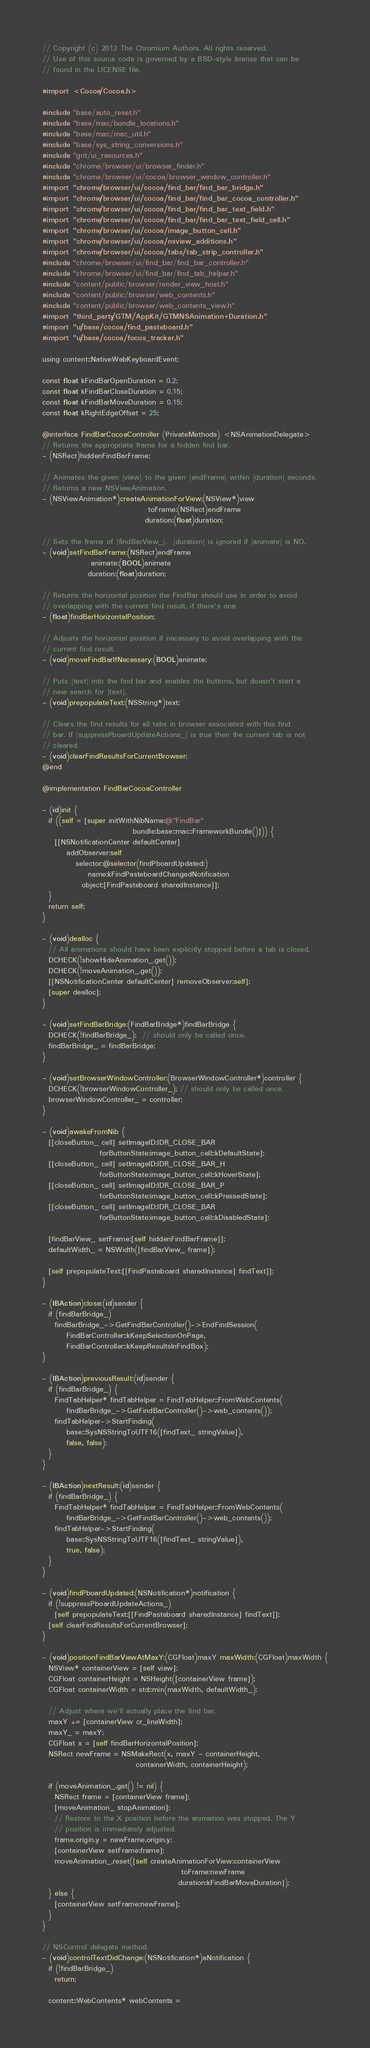Convert code to text. <code><loc_0><loc_0><loc_500><loc_500><_ObjectiveC_>// Copyright (c) 2012 The Chromium Authors. All rights reserved.
// Use of this source code is governed by a BSD-style license that can be
// found in the LICENSE file.

#import <Cocoa/Cocoa.h>

#include "base/auto_reset.h"
#include "base/mac/bundle_locations.h"
#include "base/mac/mac_util.h"
#include "base/sys_string_conversions.h"
#include "grit/ui_resources.h"
#include "chrome/browser/ui/browser_finder.h"
#include "chrome/browser/ui/cocoa/browser_window_controller.h"
#import "chrome/browser/ui/cocoa/find_bar/find_bar_bridge.h"
#import "chrome/browser/ui/cocoa/find_bar/find_bar_cocoa_controller.h"
#import "chrome/browser/ui/cocoa/find_bar/find_bar_text_field.h"
#import "chrome/browser/ui/cocoa/find_bar/find_bar_text_field_cell.h"
#import "chrome/browser/ui/cocoa/image_button_cell.h"
#import "chrome/browser/ui/cocoa/nsview_additions.h"
#import "chrome/browser/ui/cocoa/tabs/tab_strip_controller.h"
#include "chrome/browser/ui/find_bar/find_bar_controller.h"
#include "chrome/browser/ui/find_bar/find_tab_helper.h"
#include "content/public/browser/render_view_host.h"
#include "content/public/browser/web_contents.h"
#include "content/public/browser/web_contents_view.h"
#import "third_party/GTM/AppKit/GTMNSAnimation+Duration.h"
#import "ui/base/cocoa/find_pasteboard.h"
#import "ui/base/cocoa/focus_tracker.h"

using content::NativeWebKeyboardEvent;

const float kFindBarOpenDuration = 0.2;
const float kFindBarCloseDuration = 0.15;
const float kFindBarMoveDuration = 0.15;
const float kRightEdgeOffset = 25;

@interface FindBarCocoaController (PrivateMethods) <NSAnimationDelegate>
// Returns the appropriate frame for a hidden find bar.
- (NSRect)hiddenFindBarFrame;

// Animates the given |view| to the given |endFrame| within |duration| seconds.
// Returns a new NSViewAnimation.
- (NSViewAnimation*)createAnimationForView:(NSView*)view
                                   toFrame:(NSRect)endFrame
                                  duration:(float)duration;

// Sets the frame of |findBarView_|.  |duration| is ignored if |animate| is NO.
- (void)setFindBarFrame:(NSRect)endFrame
                animate:(BOOL)animate
               duration:(float)duration;

// Returns the horizontal position the FindBar should use in order to avoid
// overlapping with the current find result, if there's one.
- (float)findBarHorizontalPosition;

// Adjusts the horizontal position if necessary to avoid overlapping with the
// current find result.
- (void)moveFindBarIfNecessary:(BOOL)animate;

// Puts |text| into the find bar and enables the buttons, but doesn't start a
// new search for |text|.
- (void)prepopulateText:(NSString*)text;

// Clears the find results for all tabs in browser associated with this find
// bar. If |suppressPboardUpdateActions_| is true then the current tab is not
// cleared.
- (void)clearFindResultsForCurrentBrowser;
@end

@implementation FindBarCocoaController

- (id)init {
  if ((self = [super initWithNibName:@"FindBar"
                              bundle:base::mac::FrameworkBundle()])) {
    [[NSNotificationCenter defaultCenter]
        addObserver:self
           selector:@selector(findPboardUpdated:)
               name:kFindPasteboardChangedNotification
             object:[FindPasteboard sharedInstance]];
  }
  return self;
}

- (void)dealloc {
  // All animations should have been explicitly stopped before a tab is closed.
  DCHECK(!showHideAnimation_.get());
  DCHECK(!moveAnimation_.get());
  [[NSNotificationCenter defaultCenter] removeObserver:self];
  [super dealloc];
}

- (void)setFindBarBridge:(FindBarBridge*)findBarBridge {
  DCHECK(!findBarBridge_);  // should only be called once.
  findBarBridge_ = findBarBridge;
}

- (void)setBrowserWindowController:(BrowserWindowController*)controller {
  DCHECK(!browserWindowController_); // should only be called once.
  browserWindowController_ = controller;
}

- (void)awakeFromNib {
  [[closeButton_ cell] setImageID:IDR_CLOSE_BAR
                   forButtonState:image_button_cell::kDefaultState];
  [[closeButton_ cell] setImageID:IDR_CLOSE_BAR_H
                   forButtonState:image_button_cell::kHoverState];
  [[closeButton_ cell] setImageID:IDR_CLOSE_BAR_P
                   forButtonState:image_button_cell::kPressedState];
  [[closeButton_ cell] setImageID:IDR_CLOSE_BAR
                   forButtonState:image_button_cell::kDisabledState];

  [findBarView_ setFrame:[self hiddenFindBarFrame]];
  defaultWidth_ = NSWidth([findBarView_ frame]);

  [self prepopulateText:[[FindPasteboard sharedInstance] findText]];
}

- (IBAction)close:(id)sender {
  if (findBarBridge_)
    findBarBridge_->GetFindBarController()->EndFindSession(
        FindBarController::kKeepSelectionOnPage,
        FindBarController::kKeepResultsInFindBox);
}

- (IBAction)previousResult:(id)sender {
  if (findBarBridge_) {
    FindTabHelper* findTabHelper = FindTabHelper::FromWebContents(
        findBarBridge_->GetFindBarController()->web_contents());
    findTabHelper->StartFinding(
        base::SysNSStringToUTF16([findText_ stringValue]),
        false, false);
  }
}

- (IBAction)nextResult:(id)sender {
  if (findBarBridge_) {
    FindTabHelper* findTabHelper = FindTabHelper::FromWebContents(
        findBarBridge_->GetFindBarController()->web_contents());
    findTabHelper->StartFinding(
        base::SysNSStringToUTF16([findText_ stringValue]),
        true, false);
  }
}

- (void)findPboardUpdated:(NSNotification*)notification {
  if (!suppressPboardUpdateActions_)
    [self prepopulateText:[[FindPasteboard sharedInstance] findText]];
  [self clearFindResultsForCurrentBrowser];
}

- (void)positionFindBarViewAtMaxY:(CGFloat)maxY maxWidth:(CGFloat)maxWidth {
  NSView* containerView = [self view];
  CGFloat containerHeight = NSHeight([containerView frame]);
  CGFloat containerWidth = std::min(maxWidth, defaultWidth_);

  // Adjust where we'll actually place the find bar.
  maxY += [containerView cr_lineWidth];
  maxY_ = maxY;
  CGFloat x = [self findBarHorizontalPosition];
  NSRect newFrame = NSMakeRect(x, maxY - containerHeight,
                               containerWidth, containerHeight);

  if (moveAnimation_.get() != nil) {
    NSRect frame = [containerView frame];
    [moveAnimation_ stopAnimation];
    // Restore to the X position before the animation was stopped. The Y
    // position is immediately adjusted.
    frame.origin.y = newFrame.origin.y;
    [containerView setFrame:frame];
    moveAnimation_.reset([self createAnimationForView:containerView
                                              toFrame:newFrame
                                             duration:kFindBarMoveDuration]);
  } else {
    [containerView setFrame:newFrame];
  }
}

// NSControl delegate method.
- (void)controlTextDidChange:(NSNotification*)aNotification {
  if (!findBarBridge_)
    return;

  content::WebContents* webContents =</code> 